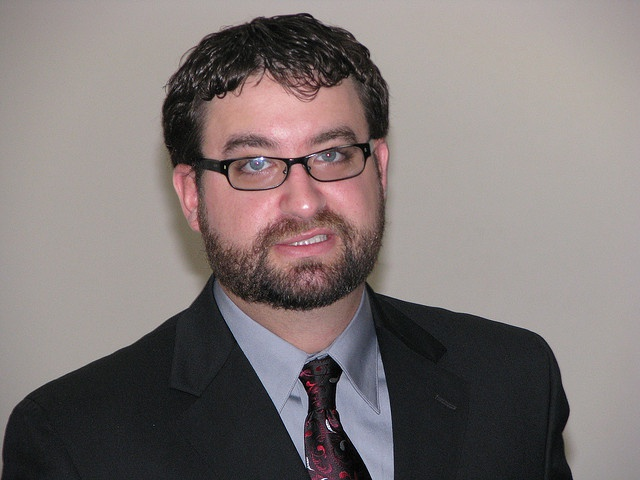Describe the objects in this image and their specific colors. I can see people in gray, black, and darkgray tones and tie in gray, black, maroon, and purple tones in this image. 